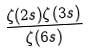<formula> <loc_0><loc_0><loc_500><loc_500>\frac { \zeta ( 2 s ) \zeta ( 3 s ) } { \zeta ( 6 s ) }</formula> 